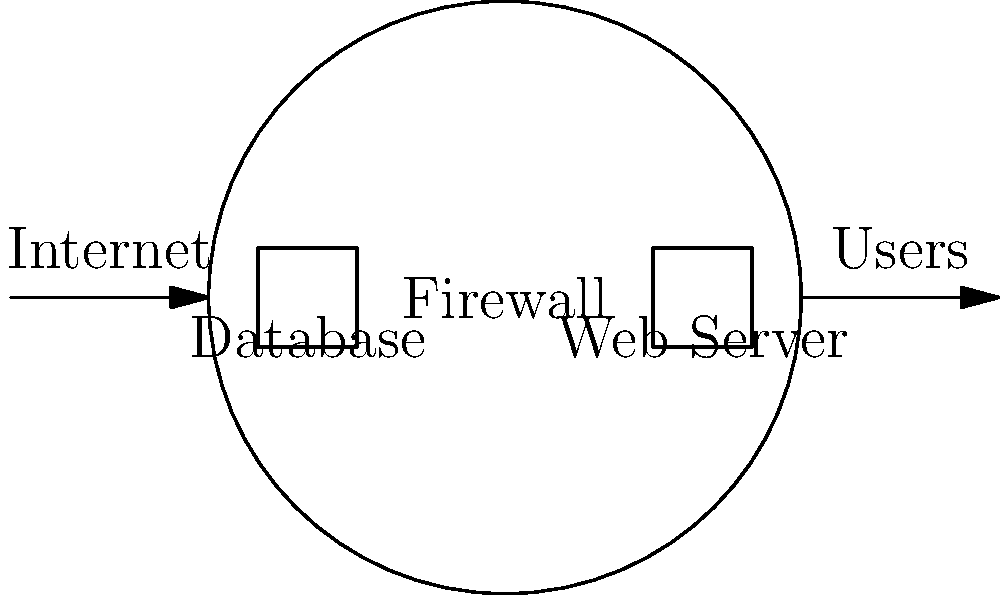In the network security architecture for protecting digitized hieroglyphic databases, which component should be placed between the database server and the web server to enhance security and control access? To enhance the security of a digitized hieroglyphic database, we need to implement a robust network security architecture. Here's a step-by-step explanation of the ideal setup:

1. Database Server: This is where the digitized hieroglyphic data is stored. It should be placed in the most secure part of the network, with limited direct access.

2. Web Server: This server hosts the application that allows users to interact with the hieroglyphic data. It should be separated from the database server.

3. Firewall: This is the critical component that should be placed between the database server and the web server. The firewall serves several important functions:
   a) It controls and monitors traffic between the two servers.
   b) It can be configured to allow only specific types of traffic and connections.
   c) It provides an additional layer of security, protecting the database from potential threats that might compromise the web server.

4. Internet-facing firewall: While not explicitly asked about in the question, it's worth noting that there should be another firewall between the web server and the internet to protect against external threats.

5. Network segmentation: The firewall helps in creating separate network segments, isolating the sensitive database from the more exposed web server.

By placing a firewall between the database and web server, we create a demilitarized zone (DMZ) architecture. This setup ensures that even if the web server is compromised, the attacker would still need to bypass the internal firewall to reach the database, significantly enhancing the overall security of the hieroglyphic data.
Answer: Firewall 